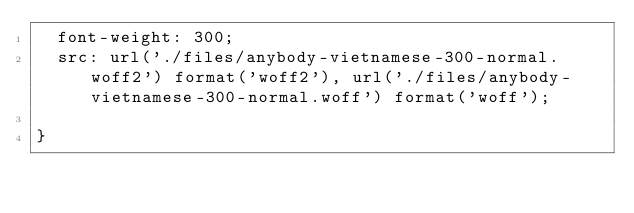Convert code to text. <code><loc_0><loc_0><loc_500><loc_500><_CSS_>  font-weight: 300;
  src: url('./files/anybody-vietnamese-300-normal.woff2') format('woff2'), url('./files/anybody-vietnamese-300-normal.woff') format('woff');
  
}
</code> 